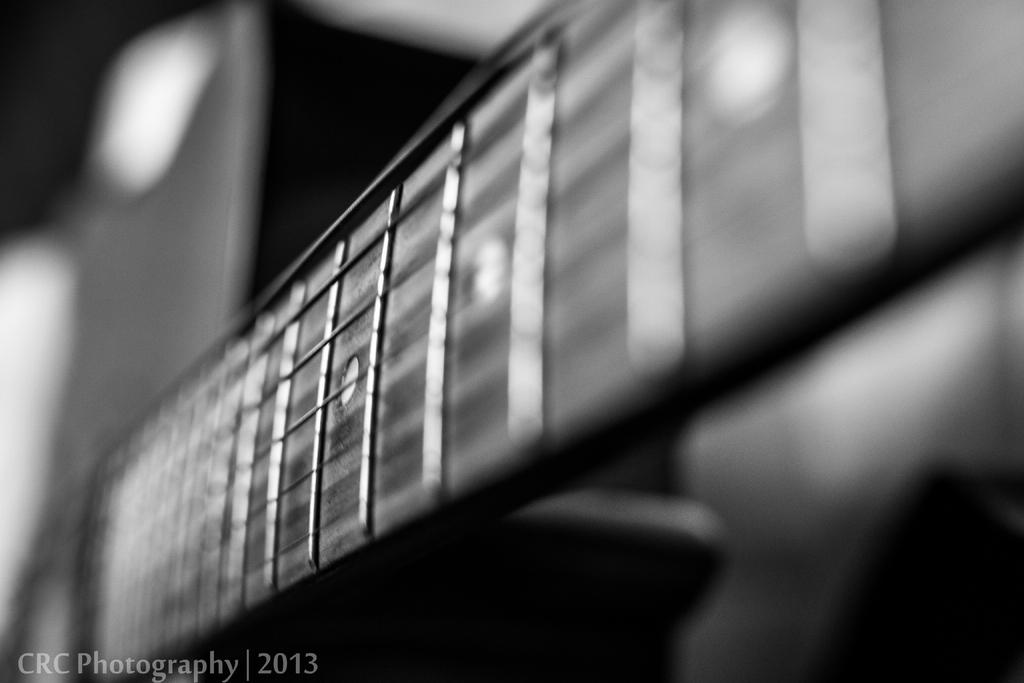What color scheme is used in the image? The image is monochrome. What type of brush is being used on the stage in the image? There is no brush or stage present in the image, as it is monochrome and does not depict any such elements. 